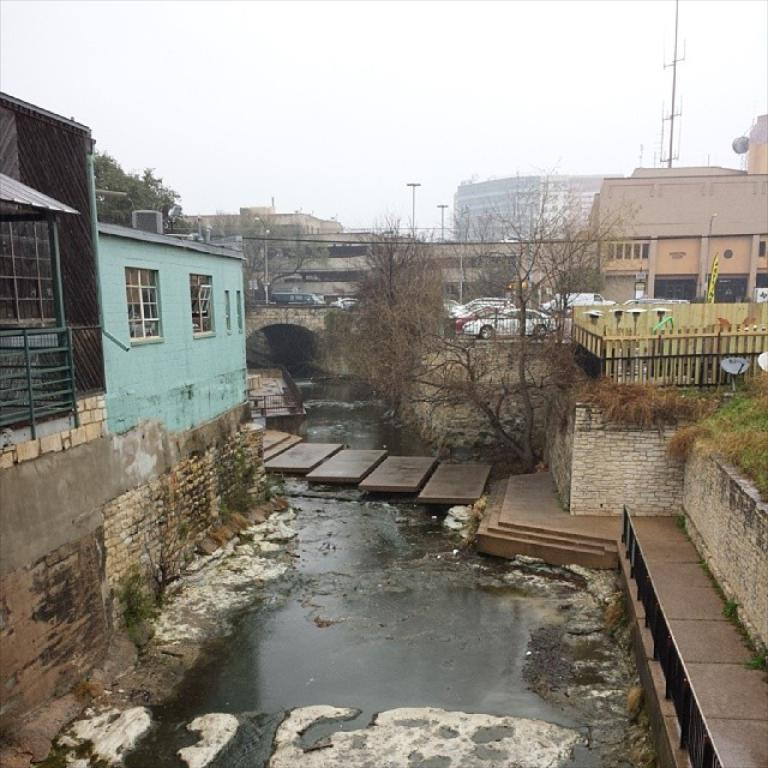What type of natural feature can be seen in the image? There is a river in the image. What structure is present over the river? There is a bridge in the image. What type of vegetation is present on both sides of the image? Trees are present on both sides of the image. What type of man-made structures are present on both sides of the image? Buildings are present on both sides of the image. What is the color of the sky in the image? The sky is white in color. Where is the drawer located in the image? There is no drawer present in the image. What type of motion can be seen in the image? The image does not depict any motion; it is a still image. 